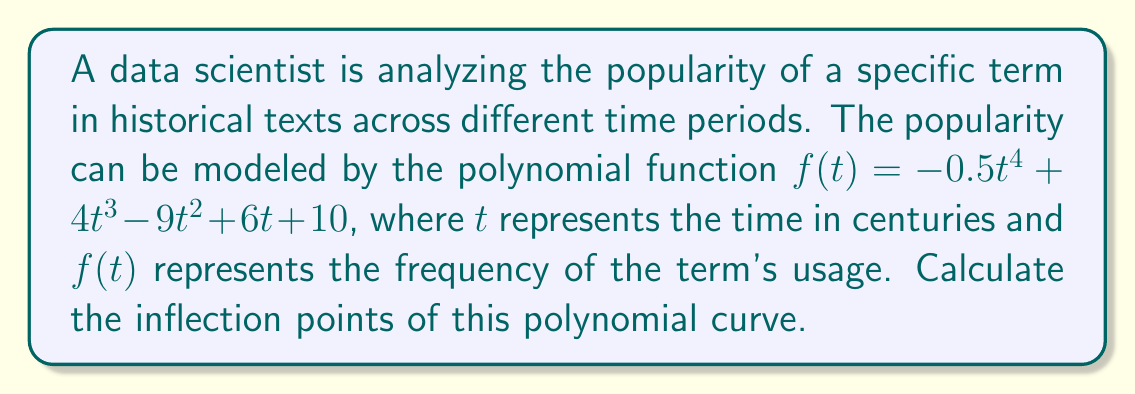Can you solve this math problem? To find the inflection points of the polynomial curve, we need to follow these steps:

1. Find the first derivative of $f(t)$:
   $$f'(t) = -2t^3 + 12t^2 - 18t + 6$$

2. Find the second derivative of $f(t)$:
   $$f''(t) = -6t^2 + 24t - 18$$

3. Set the second derivative equal to zero and solve for $t$:
   $$-6t^2 + 24t - 18 = 0$$
   $$-6(t^2 - 4t + 3) = 0$$
   $$-6(t - 1)(t - 3) = 0$$

   Solving this equation, we get $t = 1$ or $t = 3$

4. Verify that these points are indeed inflection points by checking if $f''(t)$ changes sign at these points:
   
   For $t < 1$: $f''(t)$ is negative
   For $1 < t < 3$: $f''(t)$ is positive
   For $t > 3$: $f''(t)$ is negative

   This confirms that both $t = 1$ and $t = 3$ are inflection points.

5. Calculate the $y$-coordinates of the inflection points:
   
   For $t = 1$: $f(1) = -0.5(1)^4 + 4(1)^3 - 9(1)^2 + 6(1) + 10 = 10.5$
   For $t = 3$: $f(3) = -0.5(3)^4 + 4(3)^3 - 9(3)^2 + 6(3) + 10 = 28.5$

Therefore, the inflection points are $(1, 10.5)$ and $(3, 28.5)$.
Answer: $(1, 10.5)$ and $(3, 28.5)$ 